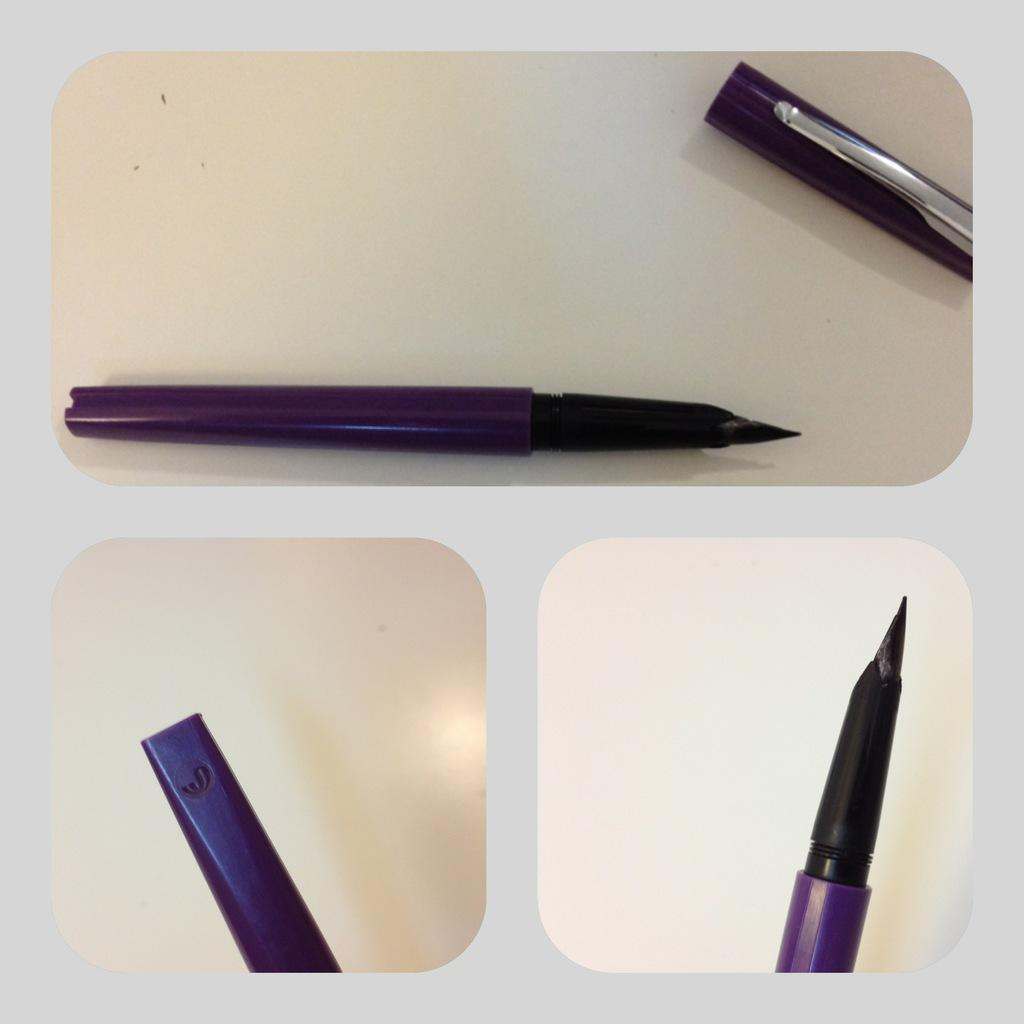What object can be seen in the image? There is a pen in the image. What colors are the pen and pen cap? The pen and pen cap are purple and silver in color. What is the color of the surface where the pen and pen cap are placed? The pen and pen cap are on a cream-colored surface. What type of organization is associated with the shirt in the image? There is no shirt present in the image, so it is not possible to associate an organization with it. 